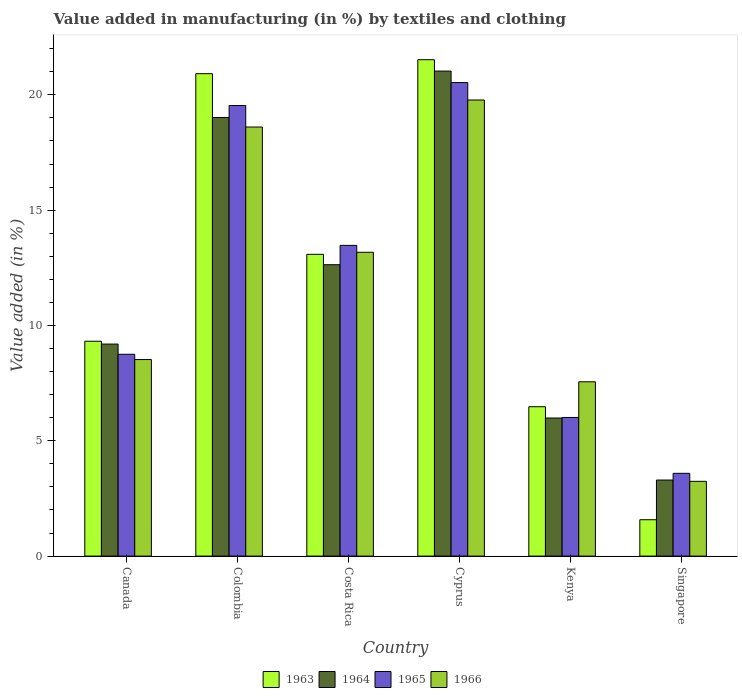How many groups of bars are there?
Your response must be concise. 6. What is the label of the 6th group of bars from the left?
Keep it short and to the point. Singapore. In how many cases, is the number of bars for a given country not equal to the number of legend labels?
Your answer should be very brief. 0. What is the percentage of value added in manufacturing by textiles and clothing in 1966 in Cyprus?
Provide a short and direct response. 19.78. Across all countries, what is the maximum percentage of value added in manufacturing by textiles and clothing in 1964?
Keep it short and to the point. 21.03. Across all countries, what is the minimum percentage of value added in manufacturing by textiles and clothing in 1963?
Keep it short and to the point. 1.58. In which country was the percentage of value added in manufacturing by textiles and clothing in 1966 maximum?
Provide a succinct answer. Cyprus. In which country was the percentage of value added in manufacturing by textiles and clothing in 1966 minimum?
Make the answer very short. Singapore. What is the total percentage of value added in manufacturing by textiles and clothing in 1963 in the graph?
Your answer should be very brief. 72.9. What is the difference between the percentage of value added in manufacturing by textiles and clothing in 1964 in Costa Rica and that in Kenya?
Keep it short and to the point. 6.65. What is the difference between the percentage of value added in manufacturing by textiles and clothing in 1966 in Costa Rica and the percentage of value added in manufacturing by textiles and clothing in 1965 in Singapore?
Keep it short and to the point. 9.58. What is the average percentage of value added in manufacturing by textiles and clothing in 1963 per country?
Make the answer very short. 12.15. What is the difference between the percentage of value added in manufacturing by textiles and clothing of/in 1963 and percentage of value added in manufacturing by textiles and clothing of/in 1964 in Costa Rica?
Give a very brief answer. 0.45. In how many countries, is the percentage of value added in manufacturing by textiles and clothing in 1964 greater than 13 %?
Offer a terse response. 2. What is the ratio of the percentage of value added in manufacturing by textiles and clothing in 1965 in Canada to that in Cyprus?
Give a very brief answer. 0.43. What is the difference between the highest and the second highest percentage of value added in manufacturing by textiles and clothing in 1965?
Keep it short and to the point. -0.99. What is the difference between the highest and the lowest percentage of value added in manufacturing by textiles and clothing in 1964?
Provide a short and direct response. 17.73. What does the 4th bar from the left in Cyprus represents?
Give a very brief answer. 1966. Are all the bars in the graph horizontal?
Offer a terse response. No. How many countries are there in the graph?
Give a very brief answer. 6. Are the values on the major ticks of Y-axis written in scientific E-notation?
Provide a succinct answer. No. What is the title of the graph?
Give a very brief answer. Value added in manufacturing (in %) by textiles and clothing. What is the label or title of the X-axis?
Offer a very short reply. Country. What is the label or title of the Y-axis?
Offer a terse response. Value added (in %). What is the Value added (in %) of 1963 in Canada?
Your answer should be compact. 9.32. What is the Value added (in %) in 1964 in Canada?
Offer a terse response. 9.19. What is the Value added (in %) in 1965 in Canada?
Your answer should be compact. 8.75. What is the Value added (in %) in 1966 in Canada?
Give a very brief answer. 8.52. What is the Value added (in %) in 1963 in Colombia?
Your answer should be very brief. 20.92. What is the Value added (in %) in 1964 in Colombia?
Your answer should be very brief. 19.02. What is the Value added (in %) of 1965 in Colombia?
Your response must be concise. 19.54. What is the Value added (in %) of 1966 in Colombia?
Your answer should be very brief. 18.6. What is the Value added (in %) in 1963 in Costa Rica?
Offer a very short reply. 13.08. What is the Value added (in %) in 1964 in Costa Rica?
Ensure brevity in your answer.  12.63. What is the Value added (in %) of 1965 in Costa Rica?
Your answer should be very brief. 13.47. What is the Value added (in %) of 1966 in Costa Rica?
Your answer should be compact. 13.17. What is the Value added (in %) of 1963 in Cyprus?
Ensure brevity in your answer.  21.52. What is the Value added (in %) in 1964 in Cyprus?
Give a very brief answer. 21.03. What is the Value added (in %) of 1965 in Cyprus?
Your response must be concise. 20.53. What is the Value added (in %) of 1966 in Cyprus?
Provide a short and direct response. 19.78. What is the Value added (in %) in 1963 in Kenya?
Ensure brevity in your answer.  6.48. What is the Value added (in %) in 1964 in Kenya?
Provide a short and direct response. 5.99. What is the Value added (in %) of 1965 in Kenya?
Your response must be concise. 6.01. What is the Value added (in %) of 1966 in Kenya?
Provide a succinct answer. 7.56. What is the Value added (in %) of 1963 in Singapore?
Give a very brief answer. 1.58. What is the Value added (in %) of 1964 in Singapore?
Make the answer very short. 3.3. What is the Value added (in %) of 1965 in Singapore?
Your response must be concise. 3.59. What is the Value added (in %) in 1966 in Singapore?
Keep it short and to the point. 3.24. Across all countries, what is the maximum Value added (in %) of 1963?
Offer a terse response. 21.52. Across all countries, what is the maximum Value added (in %) of 1964?
Make the answer very short. 21.03. Across all countries, what is the maximum Value added (in %) in 1965?
Provide a short and direct response. 20.53. Across all countries, what is the maximum Value added (in %) in 1966?
Your answer should be compact. 19.78. Across all countries, what is the minimum Value added (in %) in 1963?
Ensure brevity in your answer.  1.58. Across all countries, what is the minimum Value added (in %) in 1964?
Make the answer very short. 3.3. Across all countries, what is the minimum Value added (in %) of 1965?
Your response must be concise. 3.59. Across all countries, what is the minimum Value added (in %) in 1966?
Keep it short and to the point. 3.24. What is the total Value added (in %) in 1963 in the graph?
Provide a succinct answer. 72.9. What is the total Value added (in %) in 1964 in the graph?
Give a very brief answer. 71.16. What is the total Value added (in %) in 1965 in the graph?
Your answer should be compact. 71.89. What is the total Value added (in %) in 1966 in the graph?
Ensure brevity in your answer.  70.87. What is the difference between the Value added (in %) in 1963 in Canada and that in Colombia?
Offer a terse response. -11.6. What is the difference between the Value added (in %) in 1964 in Canada and that in Colombia?
Your answer should be very brief. -9.82. What is the difference between the Value added (in %) in 1965 in Canada and that in Colombia?
Provide a short and direct response. -10.79. What is the difference between the Value added (in %) of 1966 in Canada and that in Colombia?
Provide a short and direct response. -10.08. What is the difference between the Value added (in %) in 1963 in Canada and that in Costa Rica?
Make the answer very short. -3.77. What is the difference between the Value added (in %) of 1964 in Canada and that in Costa Rica?
Your answer should be very brief. -3.44. What is the difference between the Value added (in %) in 1965 in Canada and that in Costa Rica?
Make the answer very short. -4.72. What is the difference between the Value added (in %) in 1966 in Canada and that in Costa Rica?
Keep it short and to the point. -4.65. What is the difference between the Value added (in %) of 1963 in Canada and that in Cyprus?
Provide a succinct answer. -12.21. What is the difference between the Value added (in %) in 1964 in Canada and that in Cyprus?
Your answer should be compact. -11.84. What is the difference between the Value added (in %) of 1965 in Canada and that in Cyprus?
Your answer should be compact. -11.78. What is the difference between the Value added (in %) of 1966 in Canada and that in Cyprus?
Provide a short and direct response. -11.25. What is the difference between the Value added (in %) in 1963 in Canada and that in Kenya?
Ensure brevity in your answer.  2.84. What is the difference between the Value added (in %) in 1964 in Canada and that in Kenya?
Ensure brevity in your answer.  3.21. What is the difference between the Value added (in %) in 1965 in Canada and that in Kenya?
Give a very brief answer. 2.74. What is the difference between the Value added (in %) of 1966 in Canada and that in Kenya?
Offer a terse response. 0.96. What is the difference between the Value added (in %) of 1963 in Canada and that in Singapore?
Keep it short and to the point. 7.74. What is the difference between the Value added (in %) in 1964 in Canada and that in Singapore?
Make the answer very short. 5.9. What is the difference between the Value added (in %) in 1965 in Canada and that in Singapore?
Keep it short and to the point. 5.16. What is the difference between the Value added (in %) in 1966 in Canada and that in Singapore?
Ensure brevity in your answer.  5.28. What is the difference between the Value added (in %) of 1963 in Colombia and that in Costa Rica?
Your response must be concise. 7.83. What is the difference between the Value added (in %) in 1964 in Colombia and that in Costa Rica?
Provide a short and direct response. 6.38. What is the difference between the Value added (in %) in 1965 in Colombia and that in Costa Rica?
Your answer should be compact. 6.06. What is the difference between the Value added (in %) in 1966 in Colombia and that in Costa Rica?
Offer a very short reply. 5.43. What is the difference between the Value added (in %) in 1963 in Colombia and that in Cyprus?
Keep it short and to the point. -0.61. What is the difference between the Value added (in %) of 1964 in Colombia and that in Cyprus?
Your answer should be compact. -2.01. What is the difference between the Value added (in %) of 1965 in Colombia and that in Cyprus?
Provide a succinct answer. -0.99. What is the difference between the Value added (in %) in 1966 in Colombia and that in Cyprus?
Keep it short and to the point. -1.17. What is the difference between the Value added (in %) in 1963 in Colombia and that in Kenya?
Provide a short and direct response. 14.44. What is the difference between the Value added (in %) in 1964 in Colombia and that in Kenya?
Make the answer very short. 13.03. What is the difference between the Value added (in %) of 1965 in Colombia and that in Kenya?
Keep it short and to the point. 13.53. What is the difference between the Value added (in %) of 1966 in Colombia and that in Kenya?
Your response must be concise. 11.05. What is the difference between the Value added (in %) of 1963 in Colombia and that in Singapore?
Give a very brief answer. 19.34. What is the difference between the Value added (in %) of 1964 in Colombia and that in Singapore?
Offer a terse response. 15.72. What is the difference between the Value added (in %) in 1965 in Colombia and that in Singapore?
Keep it short and to the point. 15.95. What is the difference between the Value added (in %) of 1966 in Colombia and that in Singapore?
Give a very brief answer. 15.36. What is the difference between the Value added (in %) of 1963 in Costa Rica and that in Cyprus?
Offer a terse response. -8.44. What is the difference between the Value added (in %) in 1964 in Costa Rica and that in Cyprus?
Ensure brevity in your answer.  -8.4. What is the difference between the Value added (in %) of 1965 in Costa Rica and that in Cyprus?
Offer a terse response. -7.06. What is the difference between the Value added (in %) in 1966 in Costa Rica and that in Cyprus?
Give a very brief answer. -6.6. What is the difference between the Value added (in %) of 1963 in Costa Rica and that in Kenya?
Keep it short and to the point. 6.61. What is the difference between the Value added (in %) of 1964 in Costa Rica and that in Kenya?
Keep it short and to the point. 6.65. What is the difference between the Value added (in %) of 1965 in Costa Rica and that in Kenya?
Provide a short and direct response. 7.46. What is the difference between the Value added (in %) of 1966 in Costa Rica and that in Kenya?
Your answer should be very brief. 5.62. What is the difference between the Value added (in %) in 1963 in Costa Rica and that in Singapore?
Give a very brief answer. 11.51. What is the difference between the Value added (in %) of 1964 in Costa Rica and that in Singapore?
Provide a short and direct response. 9.34. What is the difference between the Value added (in %) of 1965 in Costa Rica and that in Singapore?
Make the answer very short. 9.88. What is the difference between the Value added (in %) of 1966 in Costa Rica and that in Singapore?
Ensure brevity in your answer.  9.93. What is the difference between the Value added (in %) in 1963 in Cyprus and that in Kenya?
Your response must be concise. 15.05. What is the difference between the Value added (in %) in 1964 in Cyprus and that in Kenya?
Offer a very short reply. 15.04. What is the difference between the Value added (in %) of 1965 in Cyprus and that in Kenya?
Your response must be concise. 14.52. What is the difference between the Value added (in %) of 1966 in Cyprus and that in Kenya?
Keep it short and to the point. 12.22. What is the difference between the Value added (in %) in 1963 in Cyprus and that in Singapore?
Your response must be concise. 19.95. What is the difference between the Value added (in %) of 1964 in Cyprus and that in Singapore?
Your answer should be compact. 17.73. What is the difference between the Value added (in %) in 1965 in Cyprus and that in Singapore?
Your response must be concise. 16.94. What is the difference between the Value added (in %) in 1966 in Cyprus and that in Singapore?
Your answer should be very brief. 16.53. What is the difference between the Value added (in %) in 1963 in Kenya and that in Singapore?
Make the answer very short. 4.9. What is the difference between the Value added (in %) of 1964 in Kenya and that in Singapore?
Your answer should be very brief. 2.69. What is the difference between the Value added (in %) of 1965 in Kenya and that in Singapore?
Offer a terse response. 2.42. What is the difference between the Value added (in %) in 1966 in Kenya and that in Singapore?
Keep it short and to the point. 4.32. What is the difference between the Value added (in %) of 1963 in Canada and the Value added (in %) of 1964 in Colombia?
Make the answer very short. -9.7. What is the difference between the Value added (in %) of 1963 in Canada and the Value added (in %) of 1965 in Colombia?
Offer a terse response. -10.22. What is the difference between the Value added (in %) in 1963 in Canada and the Value added (in %) in 1966 in Colombia?
Ensure brevity in your answer.  -9.29. What is the difference between the Value added (in %) of 1964 in Canada and the Value added (in %) of 1965 in Colombia?
Your response must be concise. -10.34. What is the difference between the Value added (in %) in 1964 in Canada and the Value added (in %) in 1966 in Colombia?
Give a very brief answer. -9.41. What is the difference between the Value added (in %) of 1965 in Canada and the Value added (in %) of 1966 in Colombia?
Provide a short and direct response. -9.85. What is the difference between the Value added (in %) of 1963 in Canada and the Value added (in %) of 1964 in Costa Rica?
Make the answer very short. -3.32. What is the difference between the Value added (in %) of 1963 in Canada and the Value added (in %) of 1965 in Costa Rica?
Offer a very short reply. -4.16. What is the difference between the Value added (in %) of 1963 in Canada and the Value added (in %) of 1966 in Costa Rica?
Make the answer very short. -3.86. What is the difference between the Value added (in %) in 1964 in Canada and the Value added (in %) in 1965 in Costa Rica?
Provide a short and direct response. -4.28. What is the difference between the Value added (in %) of 1964 in Canada and the Value added (in %) of 1966 in Costa Rica?
Provide a succinct answer. -3.98. What is the difference between the Value added (in %) in 1965 in Canada and the Value added (in %) in 1966 in Costa Rica?
Offer a very short reply. -4.42. What is the difference between the Value added (in %) of 1963 in Canada and the Value added (in %) of 1964 in Cyprus?
Your response must be concise. -11.71. What is the difference between the Value added (in %) of 1963 in Canada and the Value added (in %) of 1965 in Cyprus?
Give a very brief answer. -11.21. What is the difference between the Value added (in %) of 1963 in Canada and the Value added (in %) of 1966 in Cyprus?
Ensure brevity in your answer.  -10.46. What is the difference between the Value added (in %) of 1964 in Canada and the Value added (in %) of 1965 in Cyprus?
Your response must be concise. -11.34. What is the difference between the Value added (in %) of 1964 in Canada and the Value added (in %) of 1966 in Cyprus?
Your response must be concise. -10.58. What is the difference between the Value added (in %) in 1965 in Canada and the Value added (in %) in 1966 in Cyprus?
Keep it short and to the point. -11.02. What is the difference between the Value added (in %) in 1963 in Canada and the Value added (in %) in 1964 in Kenya?
Make the answer very short. 3.33. What is the difference between the Value added (in %) in 1963 in Canada and the Value added (in %) in 1965 in Kenya?
Provide a succinct answer. 3.31. What is the difference between the Value added (in %) of 1963 in Canada and the Value added (in %) of 1966 in Kenya?
Provide a succinct answer. 1.76. What is the difference between the Value added (in %) in 1964 in Canada and the Value added (in %) in 1965 in Kenya?
Offer a very short reply. 3.18. What is the difference between the Value added (in %) in 1964 in Canada and the Value added (in %) in 1966 in Kenya?
Your response must be concise. 1.64. What is the difference between the Value added (in %) of 1965 in Canada and the Value added (in %) of 1966 in Kenya?
Your response must be concise. 1.19. What is the difference between the Value added (in %) of 1963 in Canada and the Value added (in %) of 1964 in Singapore?
Offer a very short reply. 6.02. What is the difference between the Value added (in %) of 1963 in Canada and the Value added (in %) of 1965 in Singapore?
Make the answer very short. 5.73. What is the difference between the Value added (in %) of 1963 in Canada and the Value added (in %) of 1966 in Singapore?
Provide a short and direct response. 6.08. What is the difference between the Value added (in %) of 1964 in Canada and the Value added (in %) of 1965 in Singapore?
Keep it short and to the point. 5.6. What is the difference between the Value added (in %) of 1964 in Canada and the Value added (in %) of 1966 in Singapore?
Ensure brevity in your answer.  5.95. What is the difference between the Value added (in %) in 1965 in Canada and the Value added (in %) in 1966 in Singapore?
Provide a short and direct response. 5.51. What is the difference between the Value added (in %) of 1963 in Colombia and the Value added (in %) of 1964 in Costa Rica?
Your response must be concise. 8.28. What is the difference between the Value added (in %) in 1963 in Colombia and the Value added (in %) in 1965 in Costa Rica?
Provide a succinct answer. 7.44. What is the difference between the Value added (in %) of 1963 in Colombia and the Value added (in %) of 1966 in Costa Rica?
Give a very brief answer. 7.74. What is the difference between the Value added (in %) in 1964 in Colombia and the Value added (in %) in 1965 in Costa Rica?
Offer a very short reply. 5.55. What is the difference between the Value added (in %) of 1964 in Colombia and the Value added (in %) of 1966 in Costa Rica?
Offer a terse response. 5.84. What is the difference between the Value added (in %) of 1965 in Colombia and the Value added (in %) of 1966 in Costa Rica?
Give a very brief answer. 6.36. What is the difference between the Value added (in %) in 1963 in Colombia and the Value added (in %) in 1964 in Cyprus?
Offer a terse response. -0.11. What is the difference between the Value added (in %) in 1963 in Colombia and the Value added (in %) in 1965 in Cyprus?
Your answer should be compact. 0.39. What is the difference between the Value added (in %) in 1963 in Colombia and the Value added (in %) in 1966 in Cyprus?
Ensure brevity in your answer.  1.14. What is the difference between the Value added (in %) of 1964 in Colombia and the Value added (in %) of 1965 in Cyprus?
Offer a very short reply. -1.51. What is the difference between the Value added (in %) in 1964 in Colombia and the Value added (in %) in 1966 in Cyprus?
Provide a short and direct response. -0.76. What is the difference between the Value added (in %) in 1965 in Colombia and the Value added (in %) in 1966 in Cyprus?
Your answer should be very brief. -0.24. What is the difference between the Value added (in %) in 1963 in Colombia and the Value added (in %) in 1964 in Kenya?
Offer a terse response. 14.93. What is the difference between the Value added (in %) of 1963 in Colombia and the Value added (in %) of 1965 in Kenya?
Provide a succinct answer. 14.91. What is the difference between the Value added (in %) of 1963 in Colombia and the Value added (in %) of 1966 in Kenya?
Make the answer very short. 13.36. What is the difference between the Value added (in %) in 1964 in Colombia and the Value added (in %) in 1965 in Kenya?
Offer a terse response. 13.01. What is the difference between the Value added (in %) in 1964 in Colombia and the Value added (in %) in 1966 in Kenya?
Offer a terse response. 11.46. What is the difference between the Value added (in %) in 1965 in Colombia and the Value added (in %) in 1966 in Kenya?
Offer a very short reply. 11.98. What is the difference between the Value added (in %) of 1963 in Colombia and the Value added (in %) of 1964 in Singapore?
Your answer should be very brief. 17.62. What is the difference between the Value added (in %) in 1963 in Colombia and the Value added (in %) in 1965 in Singapore?
Your response must be concise. 17.33. What is the difference between the Value added (in %) in 1963 in Colombia and the Value added (in %) in 1966 in Singapore?
Ensure brevity in your answer.  17.68. What is the difference between the Value added (in %) in 1964 in Colombia and the Value added (in %) in 1965 in Singapore?
Make the answer very short. 15.43. What is the difference between the Value added (in %) of 1964 in Colombia and the Value added (in %) of 1966 in Singapore?
Your answer should be very brief. 15.78. What is the difference between the Value added (in %) in 1965 in Colombia and the Value added (in %) in 1966 in Singapore?
Offer a terse response. 16.3. What is the difference between the Value added (in %) in 1963 in Costa Rica and the Value added (in %) in 1964 in Cyprus?
Your response must be concise. -7.95. What is the difference between the Value added (in %) in 1963 in Costa Rica and the Value added (in %) in 1965 in Cyprus?
Offer a very short reply. -7.45. What is the difference between the Value added (in %) of 1963 in Costa Rica and the Value added (in %) of 1966 in Cyprus?
Keep it short and to the point. -6.69. What is the difference between the Value added (in %) of 1964 in Costa Rica and the Value added (in %) of 1965 in Cyprus?
Your response must be concise. -7.9. What is the difference between the Value added (in %) of 1964 in Costa Rica and the Value added (in %) of 1966 in Cyprus?
Ensure brevity in your answer.  -7.14. What is the difference between the Value added (in %) of 1965 in Costa Rica and the Value added (in %) of 1966 in Cyprus?
Your answer should be compact. -6.3. What is the difference between the Value added (in %) of 1963 in Costa Rica and the Value added (in %) of 1964 in Kenya?
Provide a short and direct response. 7.1. What is the difference between the Value added (in %) in 1963 in Costa Rica and the Value added (in %) in 1965 in Kenya?
Provide a succinct answer. 7.07. What is the difference between the Value added (in %) of 1963 in Costa Rica and the Value added (in %) of 1966 in Kenya?
Provide a succinct answer. 5.53. What is the difference between the Value added (in %) of 1964 in Costa Rica and the Value added (in %) of 1965 in Kenya?
Your answer should be compact. 6.62. What is the difference between the Value added (in %) in 1964 in Costa Rica and the Value added (in %) in 1966 in Kenya?
Ensure brevity in your answer.  5.08. What is the difference between the Value added (in %) of 1965 in Costa Rica and the Value added (in %) of 1966 in Kenya?
Your response must be concise. 5.91. What is the difference between the Value added (in %) of 1963 in Costa Rica and the Value added (in %) of 1964 in Singapore?
Provide a short and direct response. 9.79. What is the difference between the Value added (in %) of 1963 in Costa Rica and the Value added (in %) of 1965 in Singapore?
Provide a short and direct response. 9.5. What is the difference between the Value added (in %) of 1963 in Costa Rica and the Value added (in %) of 1966 in Singapore?
Your response must be concise. 9.84. What is the difference between the Value added (in %) of 1964 in Costa Rica and the Value added (in %) of 1965 in Singapore?
Offer a terse response. 9.04. What is the difference between the Value added (in %) in 1964 in Costa Rica and the Value added (in %) in 1966 in Singapore?
Give a very brief answer. 9.39. What is the difference between the Value added (in %) in 1965 in Costa Rica and the Value added (in %) in 1966 in Singapore?
Your answer should be very brief. 10.23. What is the difference between the Value added (in %) in 1963 in Cyprus and the Value added (in %) in 1964 in Kenya?
Offer a terse response. 15.54. What is the difference between the Value added (in %) in 1963 in Cyprus and the Value added (in %) in 1965 in Kenya?
Keep it short and to the point. 15.51. What is the difference between the Value added (in %) in 1963 in Cyprus and the Value added (in %) in 1966 in Kenya?
Offer a terse response. 13.97. What is the difference between the Value added (in %) in 1964 in Cyprus and the Value added (in %) in 1965 in Kenya?
Ensure brevity in your answer.  15.02. What is the difference between the Value added (in %) in 1964 in Cyprus and the Value added (in %) in 1966 in Kenya?
Make the answer very short. 13.47. What is the difference between the Value added (in %) of 1965 in Cyprus and the Value added (in %) of 1966 in Kenya?
Ensure brevity in your answer.  12.97. What is the difference between the Value added (in %) in 1963 in Cyprus and the Value added (in %) in 1964 in Singapore?
Give a very brief answer. 18.23. What is the difference between the Value added (in %) in 1963 in Cyprus and the Value added (in %) in 1965 in Singapore?
Give a very brief answer. 17.93. What is the difference between the Value added (in %) of 1963 in Cyprus and the Value added (in %) of 1966 in Singapore?
Offer a very short reply. 18.28. What is the difference between the Value added (in %) of 1964 in Cyprus and the Value added (in %) of 1965 in Singapore?
Ensure brevity in your answer.  17.44. What is the difference between the Value added (in %) in 1964 in Cyprus and the Value added (in %) in 1966 in Singapore?
Your answer should be compact. 17.79. What is the difference between the Value added (in %) in 1965 in Cyprus and the Value added (in %) in 1966 in Singapore?
Offer a terse response. 17.29. What is the difference between the Value added (in %) in 1963 in Kenya and the Value added (in %) in 1964 in Singapore?
Provide a short and direct response. 3.18. What is the difference between the Value added (in %) of 1963 in Kenya and the Value added (in %) of 1965 in Singapore?
Provide a short and direct response. 2.89. What is the difference between the Value added (in %) of 1963 in Kenya and the Value added (in %) of 1966 in Singapore?
Ensure brevity in your answer.  3.24. What is the difference between the Value added (in %) of 1964 in Kenya and the Value added (in %) of 1965 in Singapore?
Provide a short and direct response. 2.4. What is the difference between the Value added (in %) in 1964 in Kenya and the Value added (in %) in 1966 in Singapore?
Offer a terse response. 2.75. What is the difference between the Value added (in %) of 1965 in Kenya and the Value added (in %) of 1966 in Singapore?
Ensure brevity in your answer.  2.77. What is the average Value added (in %) of 1963 per country?
Provide a succinct answer. 12.15. What is the average Value added (in %) in 1964 per country?
Your response must be concise. 11.86. What is the average Value added (in %) in 1965 per country?
Offer a very short reply. 11.98. What is the average Value added (in %) of 1966 per country?
Offer a terse response. 11.81. What is the difference between the Value added (in %) in 1963 and Value added (in %) in 1964 in Canada?
Give a very brief answer. 0.12. What is the difference between the Value added (in %) of 1963 and Value added (in %) of 1965 in Canada?
Ensure brevity in your answer.  0.57. What is the difference between the Value added (in %) of 1963 and Value added (in %) of 1966 in Canada?
Make the answer very short. 0.8. What is the difference between the Value added (in %) in 1964 and Value added (in %) in 1965 in Canada?
Provide a short and direct response. 0.44. What is the difference between the Value added (in %) in 1964 and Value added (in %) in 1966 in Canada?
Your answer should be compact. 0.67. What is the difference between the Value added (in %) of 1965 and Value added (in %) of 1966 in Canada?
Give a very brief answer. 0.23. What is the difference between the Value added (in %) of 1963 and Value added (in %) of 1964 in Colombia?
Offer a very short reply. 1.9. What is the difference between the Value added (in %) in 1963 and Value added (in %) in 1965 in Colombia?
Make the answer very short. 1.38. What is the difference between the Value added (in %) in 1963 and Value added (in %) in 1966 in Colombia?
Offer a very short reply. 2.31. What is the difference between the Value added (in %) of 1964 and Value added (in %) of 1965 in Colombia?
Ensure brevity in your answer.  -0.52. What is the difference between the Value added (in %) in 1964 and Value added (in %) in 1966 in Colombia?
Your answer should be very brief. 0.41. What is the difference between the Value added (in %) in 1965 and Value added (in %) in 1966 in Colombia?
Make the answer very short. 0.93. What is the difference between the Value added (in %) in 1963 and Value added (in %) in 1964 in Costa Rica?
Keep it short and to the point. 0.45. What is the difference between the Value added (in %) of 1963 and Value added (in %) of 1965 in Costa Rica?
Offer a terse response. -0.39. What is the difference between the Value added (in %) of 1963 and Value added (in %) of 1966 in Costa Rica?
Make the answer very short. -0.09. What is the difference between the Value added (in %) of 1964 and Value added (in %) of 1965 in Costa Rica?
Provide a succinct answer. -0.84. What is the difference between the Value added (in %) in 1964 and Value added (in %) in 1966 in Costa Rica?
Give a very brief answer. -0.54. What is the difference between the Value added (in %) of 1965 and Value added (in %) of 1966 in Costa Rica?
Provide a short and direct response. 0.3. What is the difference between the Value added (in %) of 1963 and Value added (in %) of 1964 in Cyprus?
Your response must be concise. 0.49. What is the difference between the Value added (in %) in 1963 and Value added (in %) in 1966 in Cyprus?
Your response must be concise. 1.75. What is the difference between the Value added (in %) in 1964 and Value added (in %) in 1965 in Cyprus?
Your response must be concise. 0.5. What is the difference between the Value added (in %) of 1964 and Value added (in %) of 1966 in Cyprus?
Offer a very short reply. 1.25. What is the difference between the Value added (in %) in 1965 and Value added (in %) in 1966 in Cyprus?
Ensure brevity in your answer.  0.76. What is the difference between the Value added (in %) in 1963 and Value added (in %) in 1964 in Kenya?
Provide a succinct answer. 0.49. What is the difference between the Value added (in %) of 1963 and Value added (in %) of 1965 in Kenya?
Offer a very short reply. 0.47. What is the difference between the Value added (in %) in 1963 and Value added (in %) in 1966 in Kenya?
Keep it short and to the point. -1.08. What is the difference between the Value added (in %) of 1964 and Value added (in %) of 1965 in Kenya?
Make the answer very short. -0.02. What is the difference between the Value added (in %) of 1964 and Value added (in %) of 1966 in Kenya?
Your answer should be compact. -1.57. What is the difference between the Value added (in %) of 1965 and Value added (in %) of 1966 in Kenya?
Provide a short and direct response. -1.55. What is the difference between the Value added (in %) of 1963 and Value added (in %) of 1964 in Singapore?
Offer a very short reply. -1.72. What is the difference between the Value added (in %) of 1963 and Value added (in %) of 1965 in Singapore?
Make the answer very short. -2.01. What is the difference between the Value added (in %) in 1963 and Value added (in %) in 1966 in Singapore?
Give a very brief answer. -1.66. What is the difference between the Value added (in %) in 1964 and Value added (in %) in 1965 in Singapore?
Offer a very short reply. -0.29. What is the difference between the Value added (in %) in 1964 and Value added (in %) in 1966 in Singapore?
Your answer should be compact. 0.06. What is the difference between the Value added (in %) of 1965 and Value added (in %) of 1966 in Singapore?
Offer a very short reply. 0.35. What is the ratio of the Value added (in %) of 1963 in Canada to that in Colombia?
Provide a short and direct response. 0.45. What is the ratio of the Value added (in %) of 1964 in Canada to that in Colombia?
Offer a terse response. 0.48. What is the ratio of the Value added (in %) of 1965 in Canada to that in Colombia?
Your answer should be very brief. 0.45. What is the ratio of the Value added (in %) of 1966 in Canada to that in Colombia?
Provide a succinct answer. 0.46. What is the ratio of the Value added (in %) in 1963 in Canada to that in Costa Rica?
Ensure brevity in your answer.  0.71. What is the ratio of the Value added (in %) in 1964 in Canada to that in Costa Rica?
Your answer should be compact. 0.73. What is the ratio of the Value added (in %) of 1965 in Canada to that in Costa Rica?
Your response must be concise. 0.65. What is the ratio of the Value added (in %) in 1966 in Canada to that in Costa Rica?
Ensure brevity in your answer.  0.65. What is the ratio of the Value added (in %) in 1963 in Canada to that in Cyprus?
Make the answer very short. 0.43. What is the ratio of the Value added (in %) in 1964 in Canada to that in Cyprus?
Your answer should be very brief. 0.44. What is the ratio of the Value added (in %) in 1965 in Canada to that in Cyprus?
Ensure brevity in your answer.  0.43. What is the ratio of the Value added (in %) in 1966 in Canada to that in Cyprus?
Your answer should be very brief. 0.43. What is the ratio of the Value added (in %) of 1963 in Canada to that in Kenya?
Provide a short and direct response. 1.44. What is the ratio of the Value added (in %) of 1964 in Canada to that in Kenya?
Your answer should be very brief. 1.54. What is the ratio of the Value added (in %) of 1965 in Canada to that in Kenya?
Your answer should be compact. 1.46. What is the ratio of the Value added (in %) in 1966 in Canada to that in Kenya?
Your response must be concise. 1.13. What is the ratio of the Value added (in %) in 1963 in Canada to that in Singapore?
Offer a terse response. 5.91. What is the ratio of the Value added (in %) of 1964 in Canada to that in Singapore?
Your response must be concise. 2.79. What is the ratio of the Value added (in %) in 1965 in Canada to that in Singapore?
Provide a short and direct response. 2.44. What is the ratio of the Value added (in %) of 1966 in Canada to that in Singapore?
Make the answer very short. 2.63. What is the ratio of the Value added (in %) in 1963 in Colombia to that in Costa Rica?
Ensure brevity in your answer.  1.6. What is the ratio of the Value added (in %) of 1964 in Colombia to that in Costa Rica?
Make the answer very short. 1.51. What is the ratio of the Value added (in %) in 1965 in Colombia to that in Costa Rica?
Provide a short and direct response. 1.45. What is the ratio of the Value added (in %) of 1966 in Colombia to that in Costa Rica?
Keep it short and to the point. 1.41. What is the ratio of the Value added (in %) in 1963 in Colombia to that in Cyprus?
Your response must be concise. 0.97. What is the ratio of the Value added (in %) in 1964 in Colombia to that in Cyprus?
Your answer should be very brief. 0.9. What is the ratio of the Value added (in %) of 1965 in Colombia to that in Cyprus?
Provide a succinct answer. 0.95. What is the ratio of the Value added (in %) in 1966 in Colombia to that in Cyprus?
Give a very brief answer. 0.94. What is the ratio of the Value added (in %) of 1963 in Colombia to that in Kenya?
Your answer should be compact. 3.23. What is the ratio of the Value added (in %) of 1964 in Colombia to that in Kenya?
Offer a very short reply. 3.18. What is the ratio of the Value added (in %) of 1966 in Colombia to that in Kenya?
Offer a very short reply. 2.46. What is the ratio of the Value added (in %) in 1963 in Colombia to that in Singapore?
Your answer should be very brief. 13.26. What is the ratio of the Value added (in %) in 1964 in Colombia to that in Singapore?
Your response must be concise. 5.77. What is the ratio of the Value added (in %) in 1965 in Colombia to that in Singapore?
Offer a very short reply. 5.44. What is the ratio of the Value added (in %) of 1966 in Colombia to that in Singapore?
Provide a succinct answer. 5.74. What is the ratio of the Value added (in %) of 1963 in Costa Rica to that in Cyprus?
Offer a very short reply. 0.61. What is the ratio of the Value added (in %) in 1964 in Costa Rica to that in Cyprus?
Give a very brief answer. 0.6. What is the ratio of the Value added (in %) in 1965 in Costa Rica to that in Cyprus?
Keep it short and to the point. 0.66. What is the ratio of the Value added (in %) in 1966 in Costa Rica to that in Cyprus?
Provide a short and direct response. 0.67. What is the ratio of the Value added (in %) of 1963 in Costa Rica to that in Kenya?
Provide a succinct answer. 2.02. What is the ratio of the Value added (in %) in 1964 in Costa Rica to that in Kenya?
Provide a short and direct response. 2.11. What is the ratio of the Value added (in %) in 1965 in Costa Rica to that in Kenya?
Keep it short and to the point. 2.24. What is the ratio of the Value added (in %) in 1966 in Costa Rica to that in Kenya?
Provide a succinct answer. 1.74. What is the ratio of the Value added (in %) of 1963 in Costa Rica to that in Singapore?
Offer a very short reply. 8.3. What is the ratio of the Value added (in %) of 1964 in Costa Rica to that in Singapore?
Your response must be concise. 3.83. What is the ratio of the Value added (in %) in 1965 in Costa Rica to that in Singapore?
Keep it short and to the point. 3.75. What is the ratio of the Value added (in %) in 1966 in Costa Rica to that in Singapore?
Give a very brief answer. 4.06. What is the ratio of the Value added (in %) in 1963 in Cyprus to that in Kenya?
Provide a succinct answer. 3.32. What is the ratio of the Value added (in %) of 1964 in Cyprus to that in Kenya?
Your answer should be very brief. 3.51. What is the ratio of the Value added (in %) of 1965 in Cyprus to that in Kenya?
Your answer should be compact. 3.42. What is the ratio of the Value added (in %) of 1966 in Cyprus to that in Kenya?
Provide a short and direct response. 2.62. What is the ratio of the Value added (in %) in 1963 in Cyprus to that in Singapore?
Give a very brief answer. 13.65. What is the ratio of the Value added (in %) of 1964 in Cyprus to that in Singapore?
Give a very brief answer. 6.38. What is the ratio of the Value added (in %) in 1965 in Cyprus to that in Singapore?
Provide a short and direct response. 5.72. What is the ratio of the Value added (in %) in 1966 in Cyprus to that in Singapore?
Ensure brevity in your answer.  6.1. What is the ratio of the Value added (in %) in 1963 in Kenya to that in Singapore?
Offer a terse response. 4.11. What is the ratio of the Value added (in %) in 1964 in Kenya to that in Singapore?
Your response must be concise. 1.82. What is the ratio of the Value added (in %) in 1965 in Kenya to that in Singapore?
Give a very brief answer. 1.67. What is the ratio of the Value added (in %) in 1966 in Kenya to that in Singapore?
Offer a very short reply. 2.33. What is the difference between the highest and the second highest Value added (in %) in 1963?
Offer a terse response. 0.61. What is the difference between the highest and the second highest Value added (in %) of 1964?
Give a very brief answer. 2.01. What is the difference between the highest and the second highest Value added (in %) of 1966?
Offer a very short reply. 1.17. What is the difference between the highest and the lowest Value added (in %) in 1963?
Keep it short and to the point. 19.95. What is the difference between the highest and the lowest Value added (in %) in 1964?
Your answer should be compact. 17.73. What is the difference between the highest and the lowest Value added (in %) of 1965?
Your answer should be very brief. 16.94. What is the difference between the highest and the lowest Value added (in %) of 1966?
Ensure brevity in your answer.  16.53. 